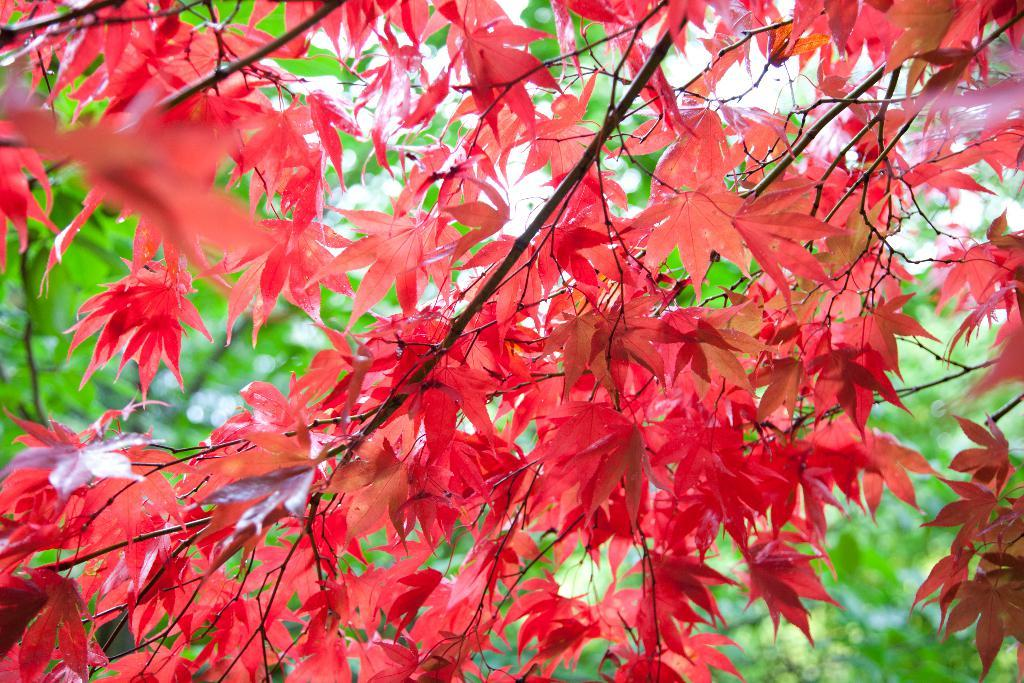What type of tree is present in the image? There is a tree with red color leaves in the image. Can you describe the background of the image? There are trees in the background of the image. What type of bean is being prepared by the father in the image? There is no father or bean present in the image; it only features a tree with red leaves and trees in the background. 